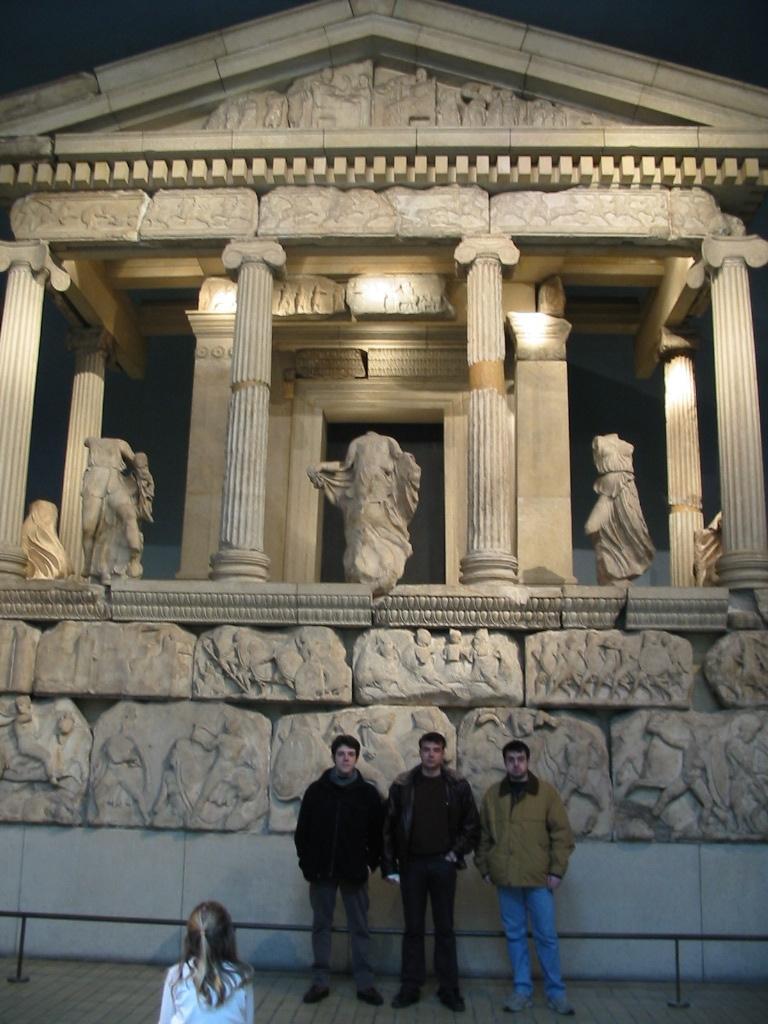Can you describe this image briefly? In this image I can see in the middle three men are standing, they wore coats, trousers, shoes. At the top it looks like an old construction with the statues. 